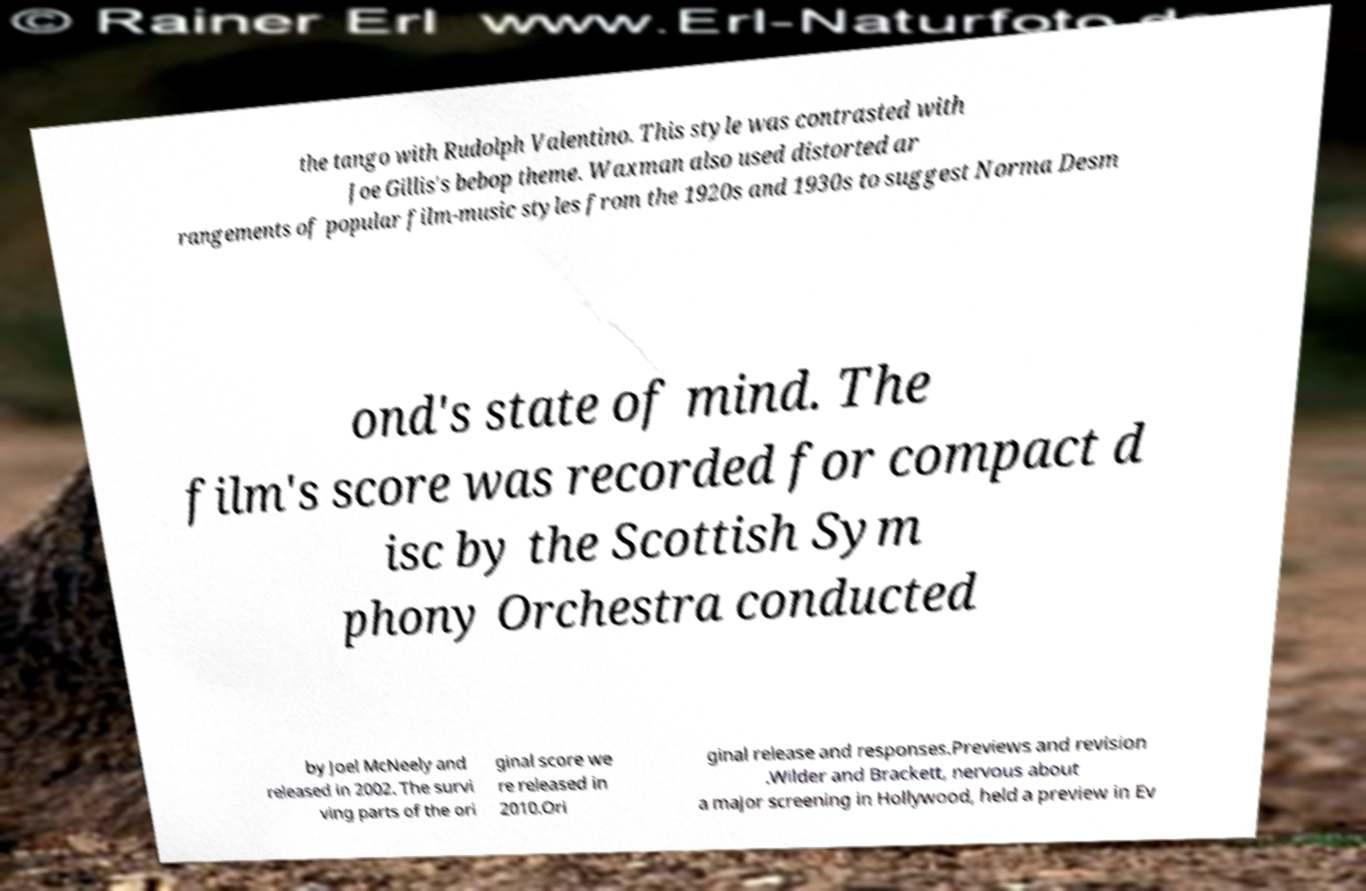Please read and relay the text visible in this image. What does it say? the tango with Rudolph Valentino. This style was contrasted with Joe Gillis's bebop theme. Waxman also used distorted ar rangements of popular film-music styles from the 1920s and 1930s to suggest Norma Desm ond's state of mind. The film's score was recorded for compact d isc by the Scottish Sym phony Orchestra conducted by Joel McNeely and released in 2002. The survi ving parts of the ori ginal score we re released in 2010.Ori ginal release and responses.Previews and revision .Wilder and Brackett, nervous about a major screening in Hollywood, held a preview in Ev 